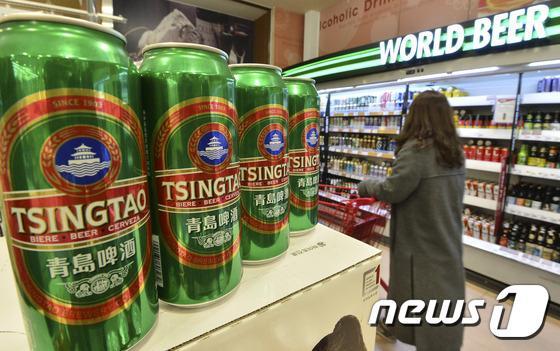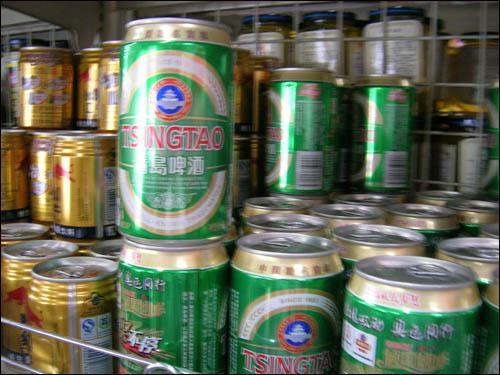The first image is the image on the left, the second image is the image on the right. For the images displayed, is the sentence "There are exactly five bottles of beer in the left image." factually correct? Answer yes or no. No. 